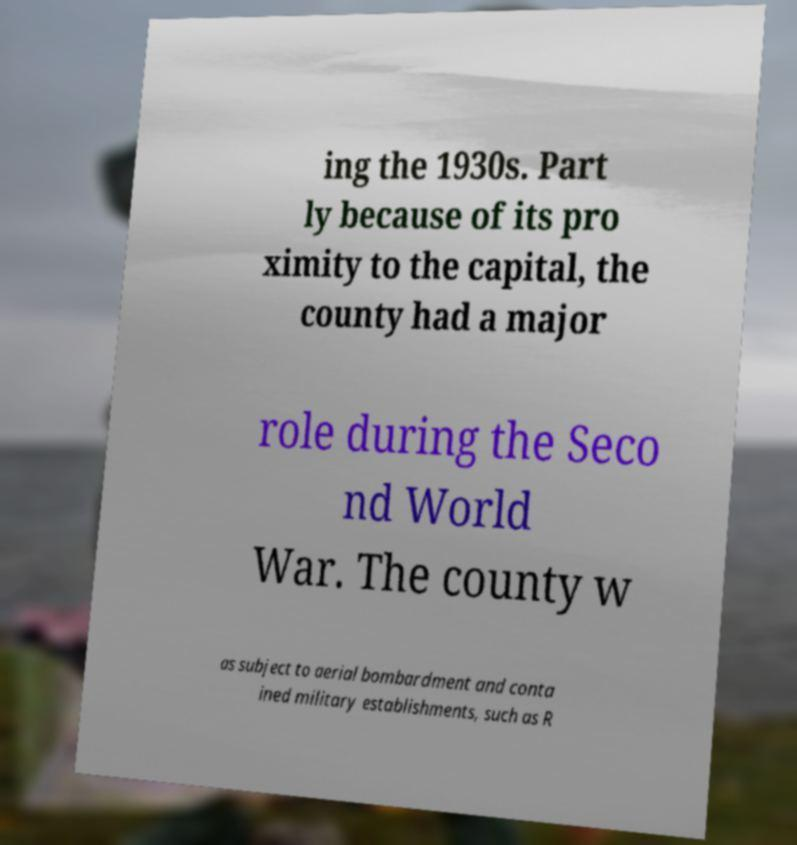There's text embedded in this image that I need extracted. Can you transcribe it verbatim? ing the 1930s. Part ly because of its pro ximity to the capital, the county had a major role during the Seco nd World War. The county w as subject to aerial bombardment and conta ined military establishments, such as R 